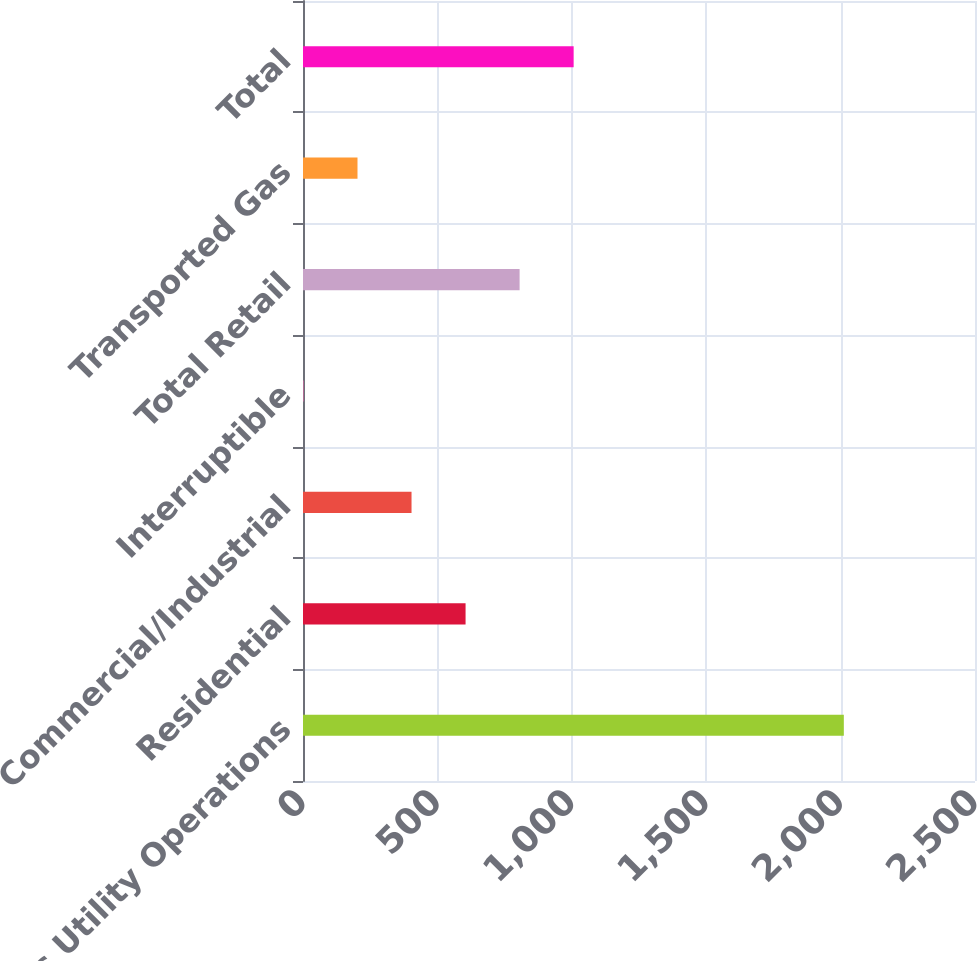<chart> <loc_0><loc_0><loc_500><loc_500><bar_chart><fcel>Gas Utility Operations<fcel>Residential<fcel>Commercial/Industrial<fcel>Interruptible<fcel>Total Retail<fcel>Transported Gas<fcel>Total<nl><fcel>2012<fcel>604.79<fcel>403.76<fcel>1.7<fcel>805.82<fcel>202.73<fcel>1006.85<nl></chart> 